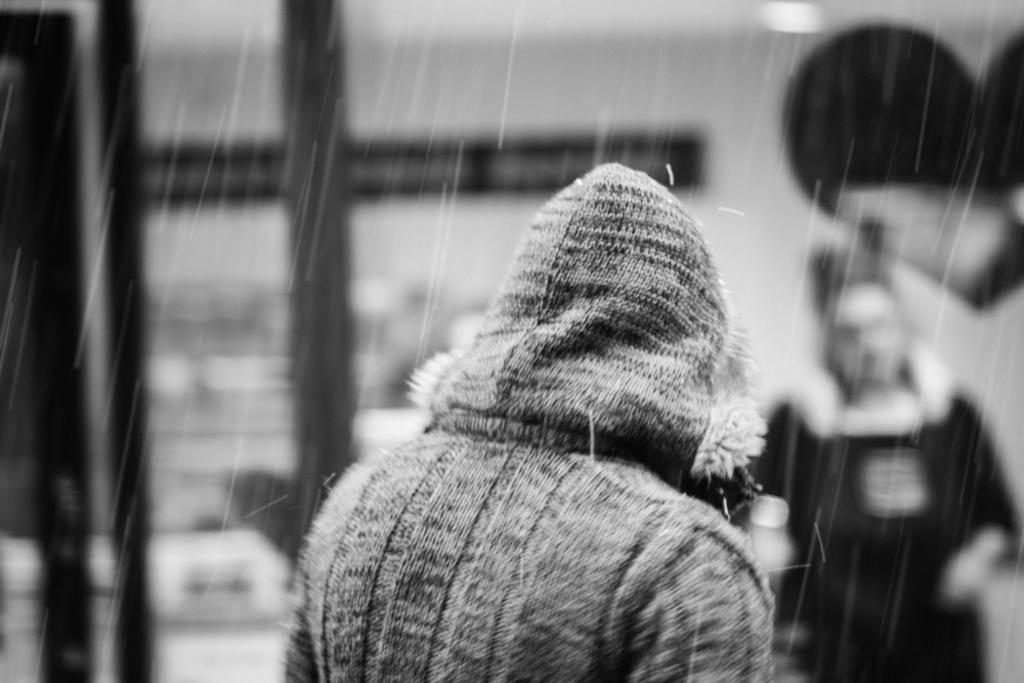What is the person in the foreground of the image wearing? The person in the image is wearing a jacket. What is the weather like in the image? It appears to be raining in the image. Can you describe the person in the background of the image? There is another person in the background of the image, but their appearance is not clear due to the blurred background. What type of tub is visible in the image? There is no tub present in the image. How does the guide help the person in the image? There is no guide present in the image, so it is not possible to answer how a guide might help the person. 